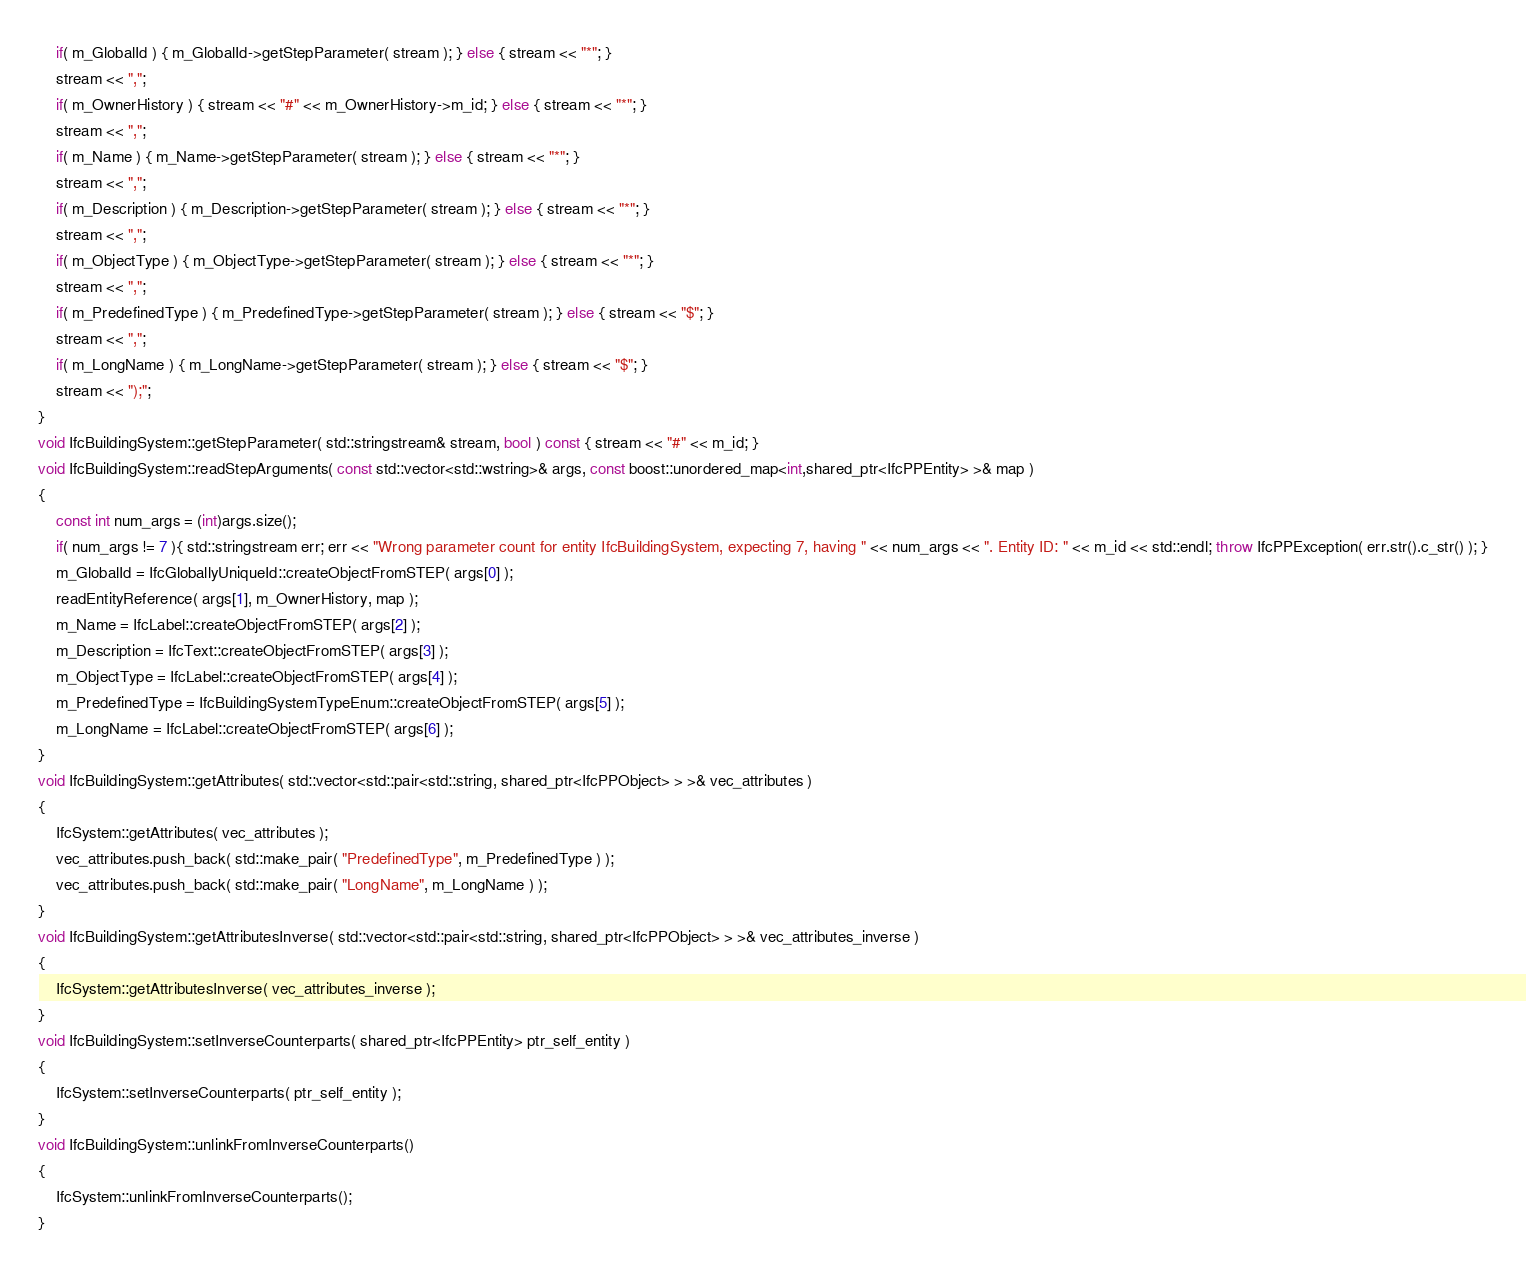<code> <loc_0><loc_0><loc_500><loc_500><_C++_>	if( m_GlobalId ) { m_GlobalId->getStepParameter( stream ); } else { stream << "*"; }
	stream << ",";
	if( m_OwnerHistory ) { stream << "#" << m_OwnerHistory->m_id; } else { stream << "*"; }
	stream << ",";
	if( m_Name ) { m_Name->getStepParameter( stream ); } else { stream << "*"; }
	stream << ",";
	if( m_Description ) { m_Description->getStepParameter( stream ); } else { stream << "*"; }
	stream << ",";
	if( m_ObjectType ) { m_ObjectType->getStepParameter( stream ); } else { stream << "*"; }
	stream << ",";
	if( m_PredefinedType ) { m_PredefinedType->getStepParameter( stream ); } else { stream << "$"; }
	stream << ",";
	if( m_LongName ) { m_LongName->getStepParameter( stream ); } else { stream << "$"; }
	stream << ");";
}
void IfcBuildingSystem::getStepParameter( std::stringstream& stream, bool ) const { stream << "#" << m_id; }
void IfcBuildingSystem::readStepArguments( const std::vector<std::wstring>& args, const boost::unordered_map<int,shared_ptr<IfcPPEntity> >& map )
{
	const int num_args = (int)args.size();
	if( num_args != 7 ){ std::stringstream err; err << "Wrong parameter count for entity IfcBuildingSystem, expecting 7, having " << num_args << ". Entity ID: " << m_id << std::endl; throw IfcPPException( err.str().c_str() ); }
	m_GlobalId = IfcGloballyUniqueId::createObjectFromSTEP( args[0] );
	readEntityReference( args[1], m_OwnerHistory, map );
	m_Name = IfcLabel::createObjectFromSTEP( args[2] );
	m_Description = IfcText::createObjectFromSTEP( args[3] );
	m_ObjectType = IfcLabel::createObjectFromSTEP( args[4] );
	m_PredefinedType = IfcBuildingSystemTypeEnum::createObjectFromSTEP( args[5] );
	m_LongName = IfcLabel::createObjectFromSTEP( args[6] );
}
void IfcBuildingSystem::getAttributes( std::vector<std::pair<std::string, shared_ptr<IfcPPObject> > >& vec_attributes )
{
	IfcSystem::getAttributes( vec_attributes );
	vec_attributes.push_back( std::make_pair( "PredefinedType", m_PredefinedType ) );
	vec_attributes.push_back( std::make_pair( "LongName", m_LongName ) );
}
void IfcBuildingSystem::getAttributesInverse( std::vector<std::pair<std::string, shared_ptr<IfcPPObject> > >& vec_attributes_inverse )
{
	IfcSystem::getAttributesInverse( vec_attributes_inverse );
}
void IfcBuildingSystem::setInverseCounterparts( shared_ptr<IfcPPEntity> ptr_self_entity )
{
	IfcSystem::setInverseCounterparts( ptr_self_entity );
}
void IfcBuildingSystem::unlinkFromInverseCounterparts()
{
	IfcSystem::unlinkFromInverseCounterparts();
}
</code> 